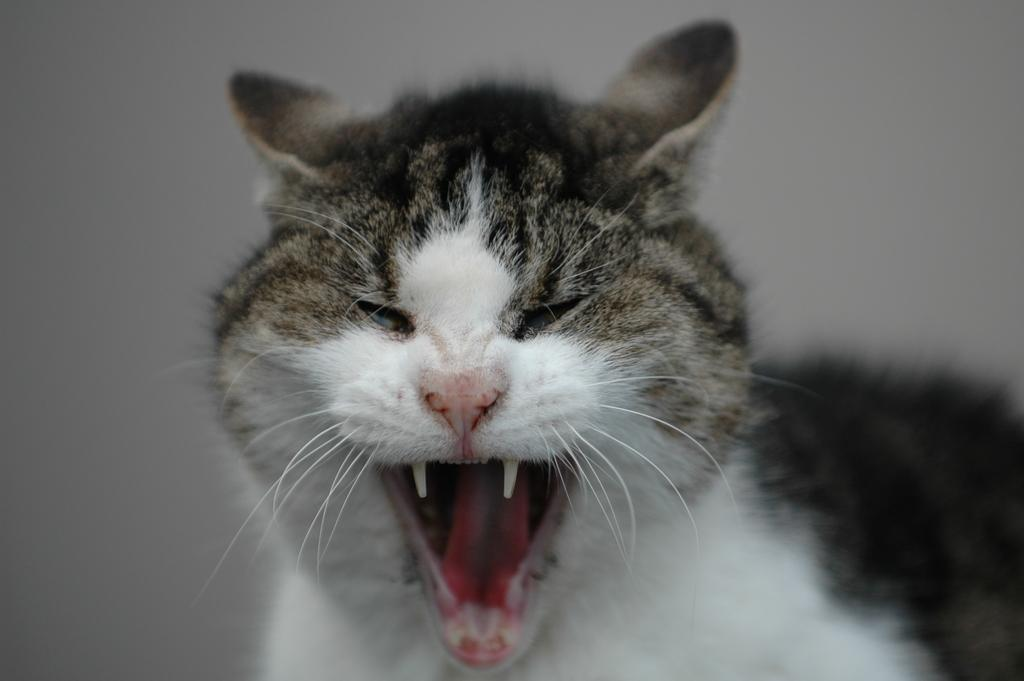What type of animal is present in the image? There is a cat in the image. Can you describe the visual quality of the image? The edges of the image are blurred. What type of expansion is visible in the image? There is no expansion visible in the image; it features a cat and blurred edges. Can you see a net in the image? There is no net present in the image. 